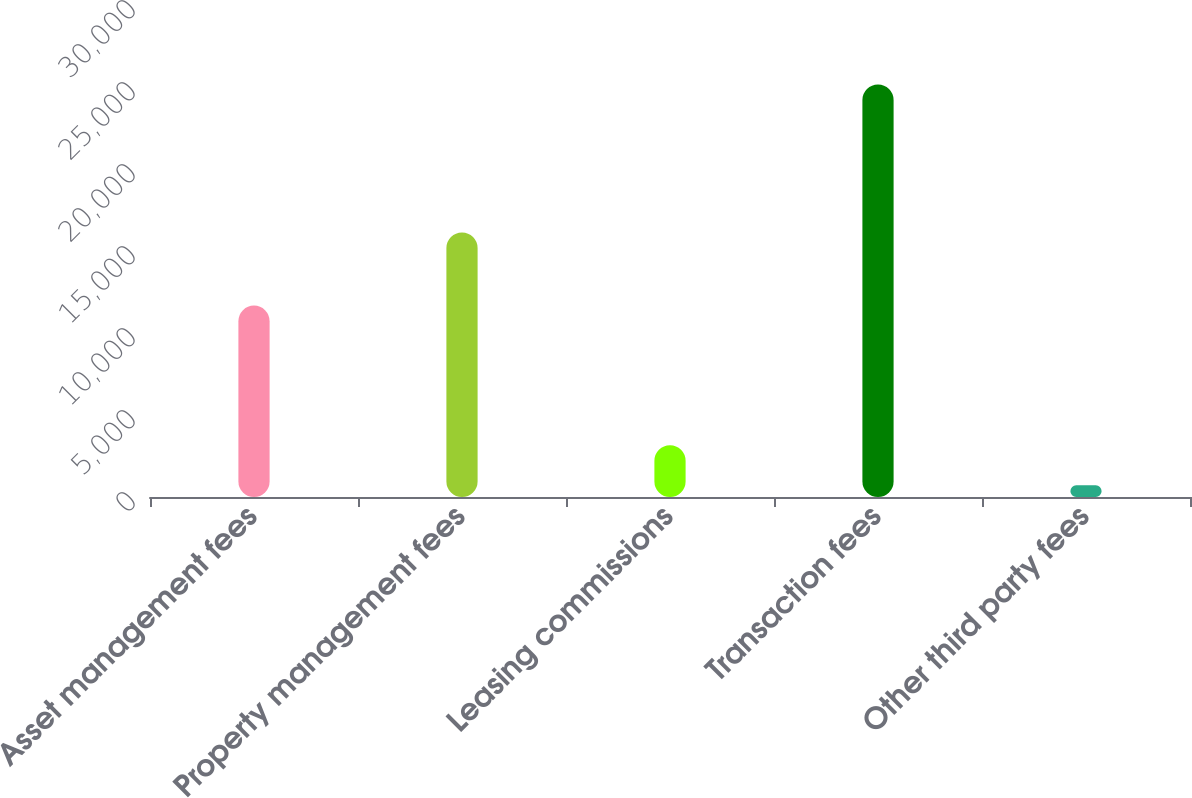<chart> <loc_0><loc_0><loc_500><loc_500><bar_chart><fcel>Asset management fees<fcel>Property management fees<fcel>Leasing commissions<fcel>Transaction fees<fcel>Other third party fees<nl><fcel>11673<fcel>16132<fcel>3153.6<fcel>25155<fcel>709<nl></chart> 